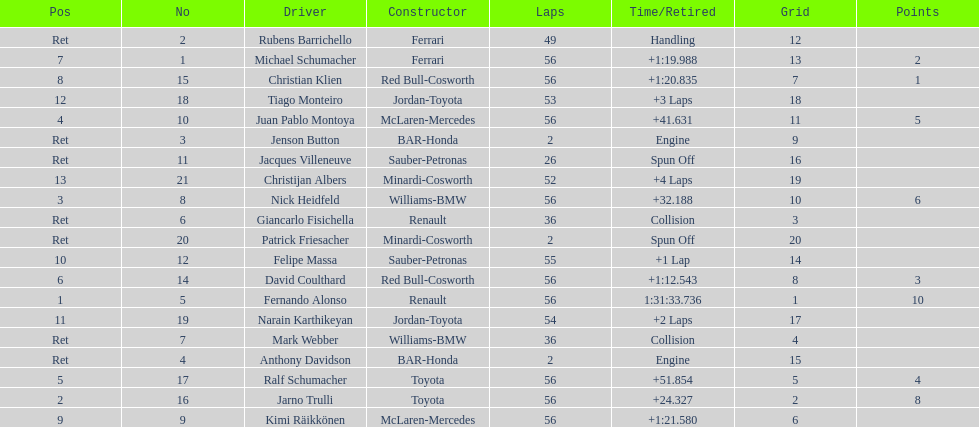Who completed the race ahead of nick heidfeld? Jarno Trulli. 